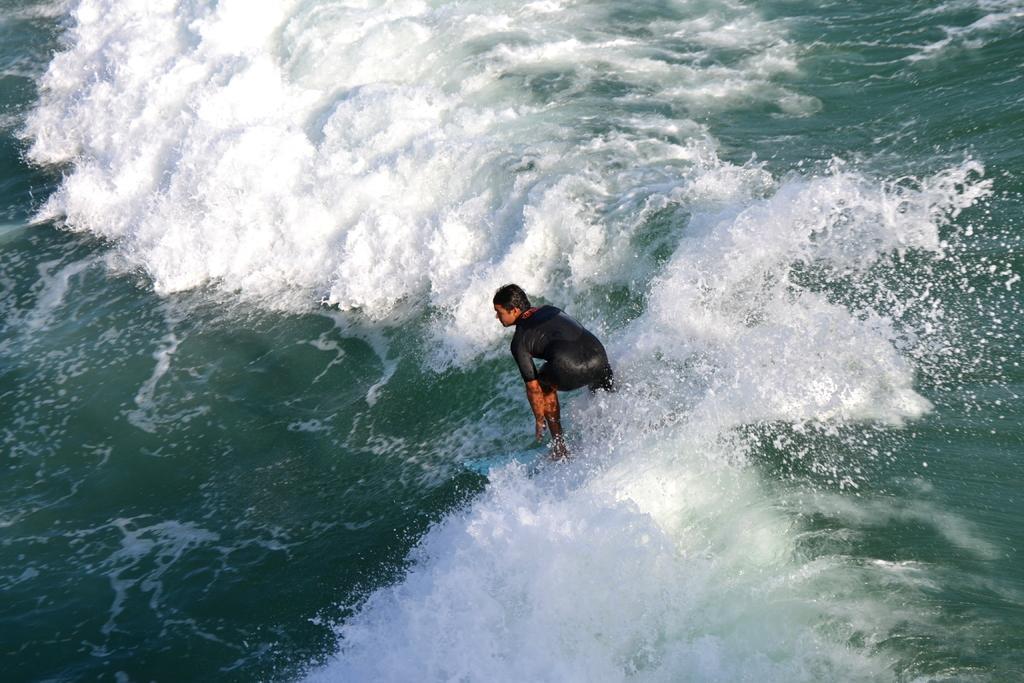In one or two sentences, can you explain what this image depicts? In the center of the image there is a person surfing on the water. 